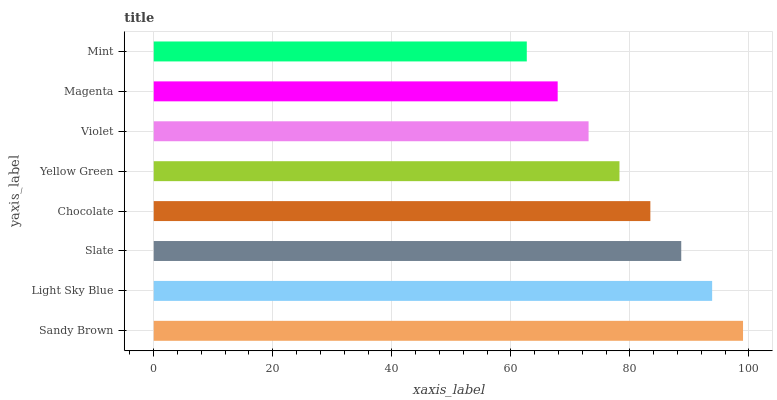Is Mint the minimum?
Answer yes or no. Yes. Is Sandy Brown the maximum?
Answer yes or no. Yes. Is Light Sky Blue the minimum?
Answer yes or no. No. Is Light Sky Blue the maximum?
Answer yes or no. No. Is Sandy Brown greater than Light Sky Blue?
Answer yes or no. Yes. Is Light Sky Blue less than Sandy Brown?
Answer yes or no. Yes. Is Light Sky Blue greater than Sandy Brown?
Answer yes or no. No. Is Sandy Brown less than Light Sky Blue?
Answer yes or no. No. Is Chocolate the high median?
Answer yes or no. Yes. Is Yellow Green the low median?
Answer yes or no. Yes. Is Yellow Green the high median?
Answer yes or no. No. Is Sandy Brown the low median?
Answer yes or no. No. 